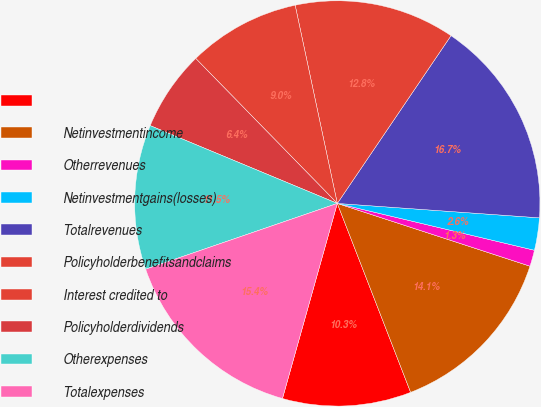Convert chart. <chart><loc_0><loc_0><loc_500><loc_500><pie_chart><ecel><fcel>Netinvestmentincome<fcel>Otherrevenues<fcel>Netinvestmentgains(losses)<fcel>Totalrevenues<fcel>Policyholderbenefitsandclaims<fcel>Interest credited to<fcel>Policyholderdividends<fcel>Otherexpenses<fcel>Totalexpenses<nl><fcel>10.26%<fcel>14.1%<fcel>1.3%<fcel>2.58%<fcel>16.66%<fcel>12.82%<fcel>8.98%<fcel>6.42%<fcel>11.54%<fcel>15.38%<nl></chart> 